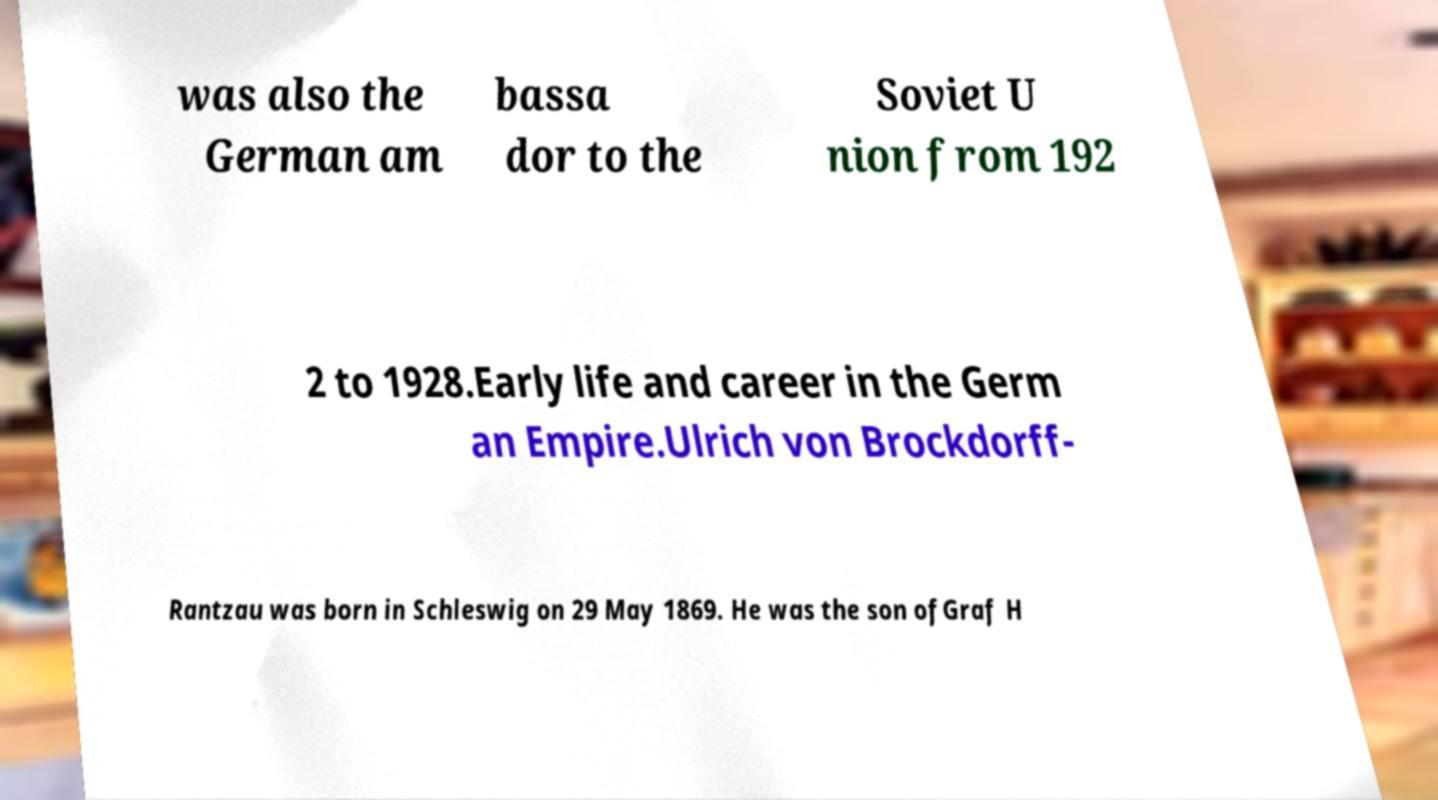Please read and relay the text visible in this image. What does it say? was also the German am bassa dor to the Soviet U nion from 192 2 to 1928.Early life and career in the Germ an Empire.Ulrich von Brockdorff- Rantzau was born in Schleswig on 29 May 1869. He was the son ofGraf H 